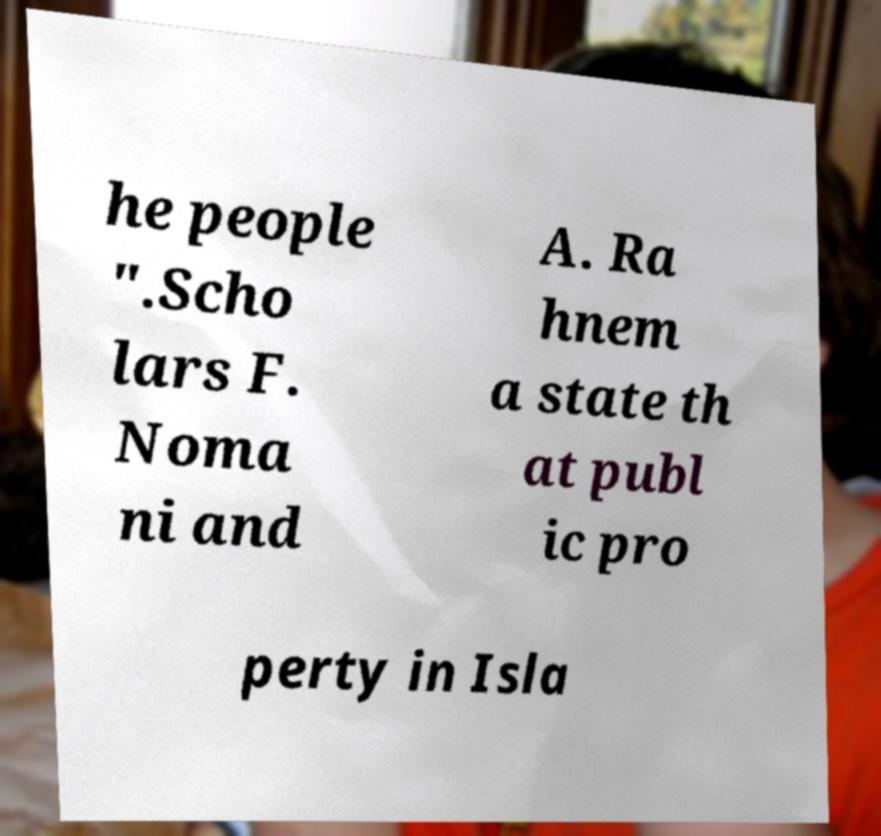Could you assist in decoding the text presented in this image and type it out clearly? he people ".Scho lars F. Noma ni and A. Ra hnem a state th at publ ic pro perty in Isla 